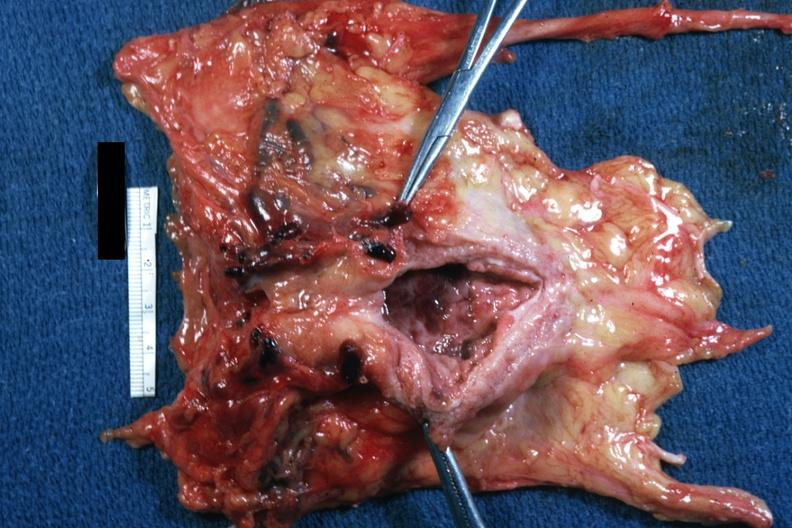what is present?
Answer the question using a single word or phrase. Prostate 